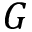Convert formula to latex. <formula><loc_0><loc_0><loc_500><loc_500>G</formula> 